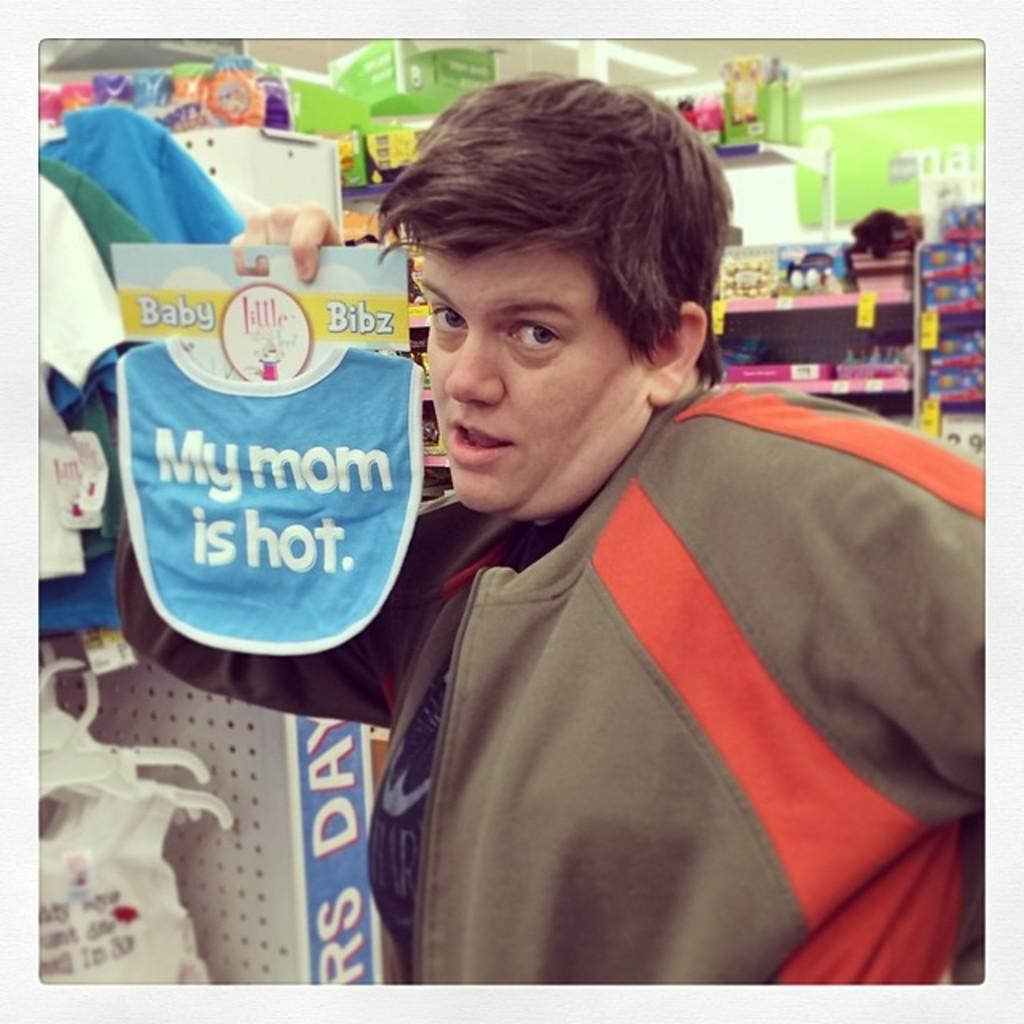<image>
Describe the image concisely. A young man holds up a baby bib with the message "My mom is hot" on it. 